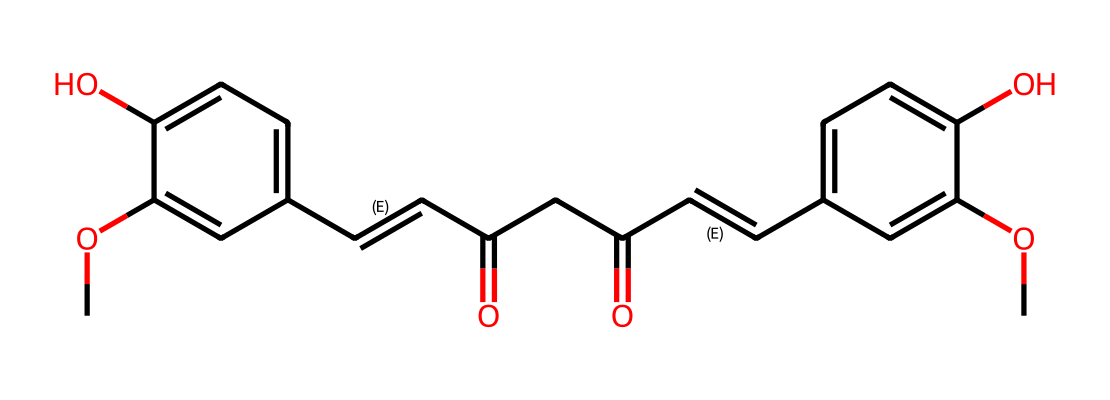What is the total number of carbon atoms in the curcumin structure? To determine the total number of carbon atoms, we can count each 'C' in the SMILES representation. The structure has multiple 'C' entries, which add up to 21 carbon atoms when analyzed.
Answer: 21 How many hydroxyl (–OH) groups are present in curcumin? The presence of hydroxyl groups can be identified by locating 'O' followed by hydrogen atoms in the structure. In the SMILES, there are two occurrences in the aromatic rings indicating two hydroxyl groups.
Answer: 2 What is the main functional group characteristic of curcumin? The structure of curcumin contains multiple functional groups, but the most characteristic one is the phenolic group identified by its benzene ring with hydroxyl substitutions. This attribute significantly contributes to its antioxidant properties.
Answer: phenolic How many double bonds are present in curcumin? Double bonds are indicated by the '/C=C/' notation in the SMILES. Upon close inspection, there are three such instances indicating a total of three double bonds in the curcumin structure.
Answer: 3 What is the relationship of curcumin to antioxidants? Curcumin acts as a potent antioxidant, as indicated by its molecular structure which features dual aromatic rings, allowing for effective scavenging of free radicals, a key activity in antioxidants.
Answer: potent antioxidant Which two elements dominate the molecular composition of curcumin? By examining the SMILES structure, we can observe that the majority of atoms present are carbon and oxygen, showing that these two elements are predominant in the molecular composition of curcumin.
Answer: carbon and oxygen 